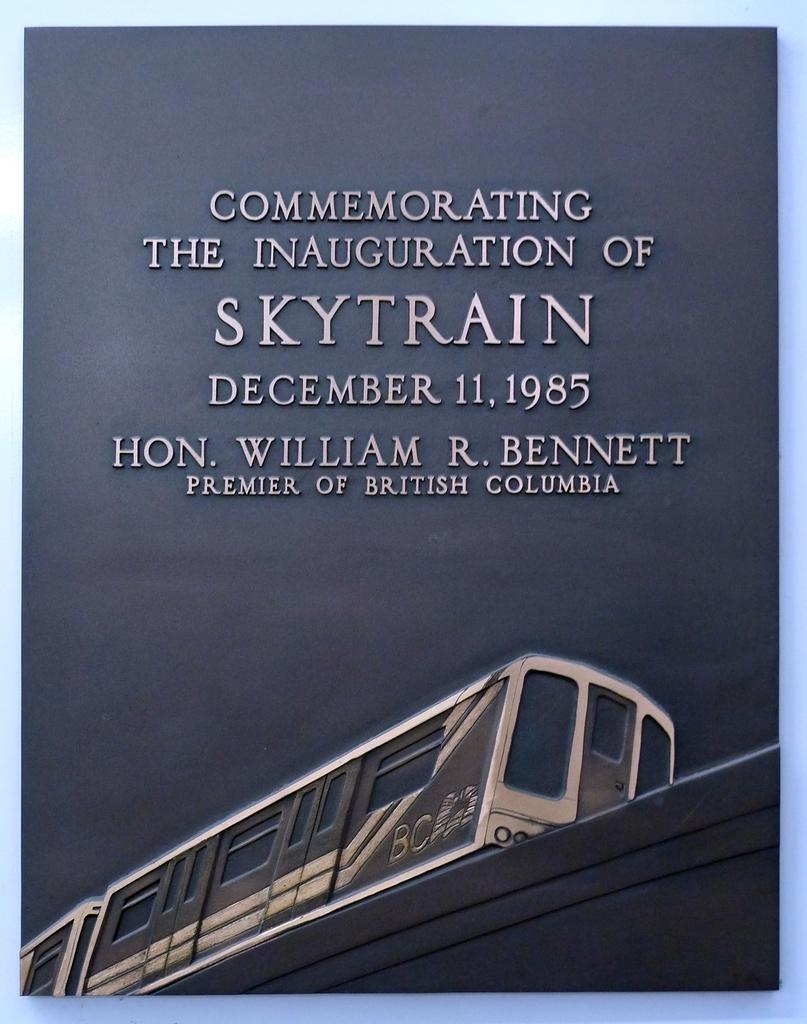What is the context of the image? The image is in a book. What is the main subject of the image? There is a train in the image. Where is the train located in the image? The train is at the bottom of the image. What is the mother doing in the image? There is no mother present in the image; it features a train at the bottom of the image. What is the purpose of the book in the image? The image does not show the purpose of the book; it only shows a train at the bottom of the image. 